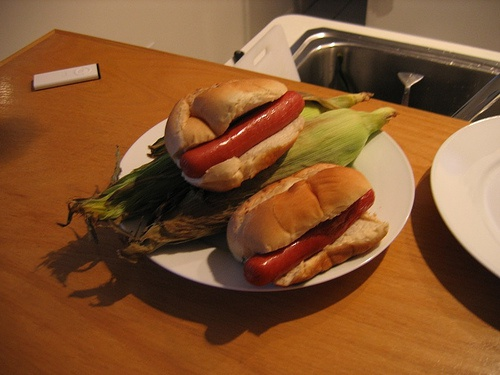Describe the objects in this image and their specific colors. I can see dining table in brown, black, maroon, and tan tones, hot dog in brown, maroon, and tan tones, and sink in brown, black, maroon, and gray tones in this image. 